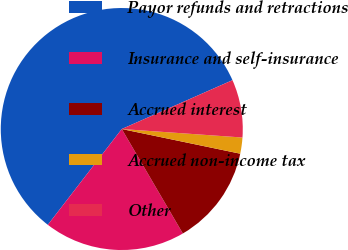Convert chart to OTSL. <chart><loc_0><loc_0><loc_500><loc_500><pie_chart><fcel>Payor refunds and retractions<fcel>Insurance and self-insurance<fcel>Accrued interest<fcel>Accrued non-income tax<fcel>Other<nl><fcel>57.92%<fcel>18.88%<fcel>13.31%<fcel>2.15%<fcel>7.73%<nl></chart> 